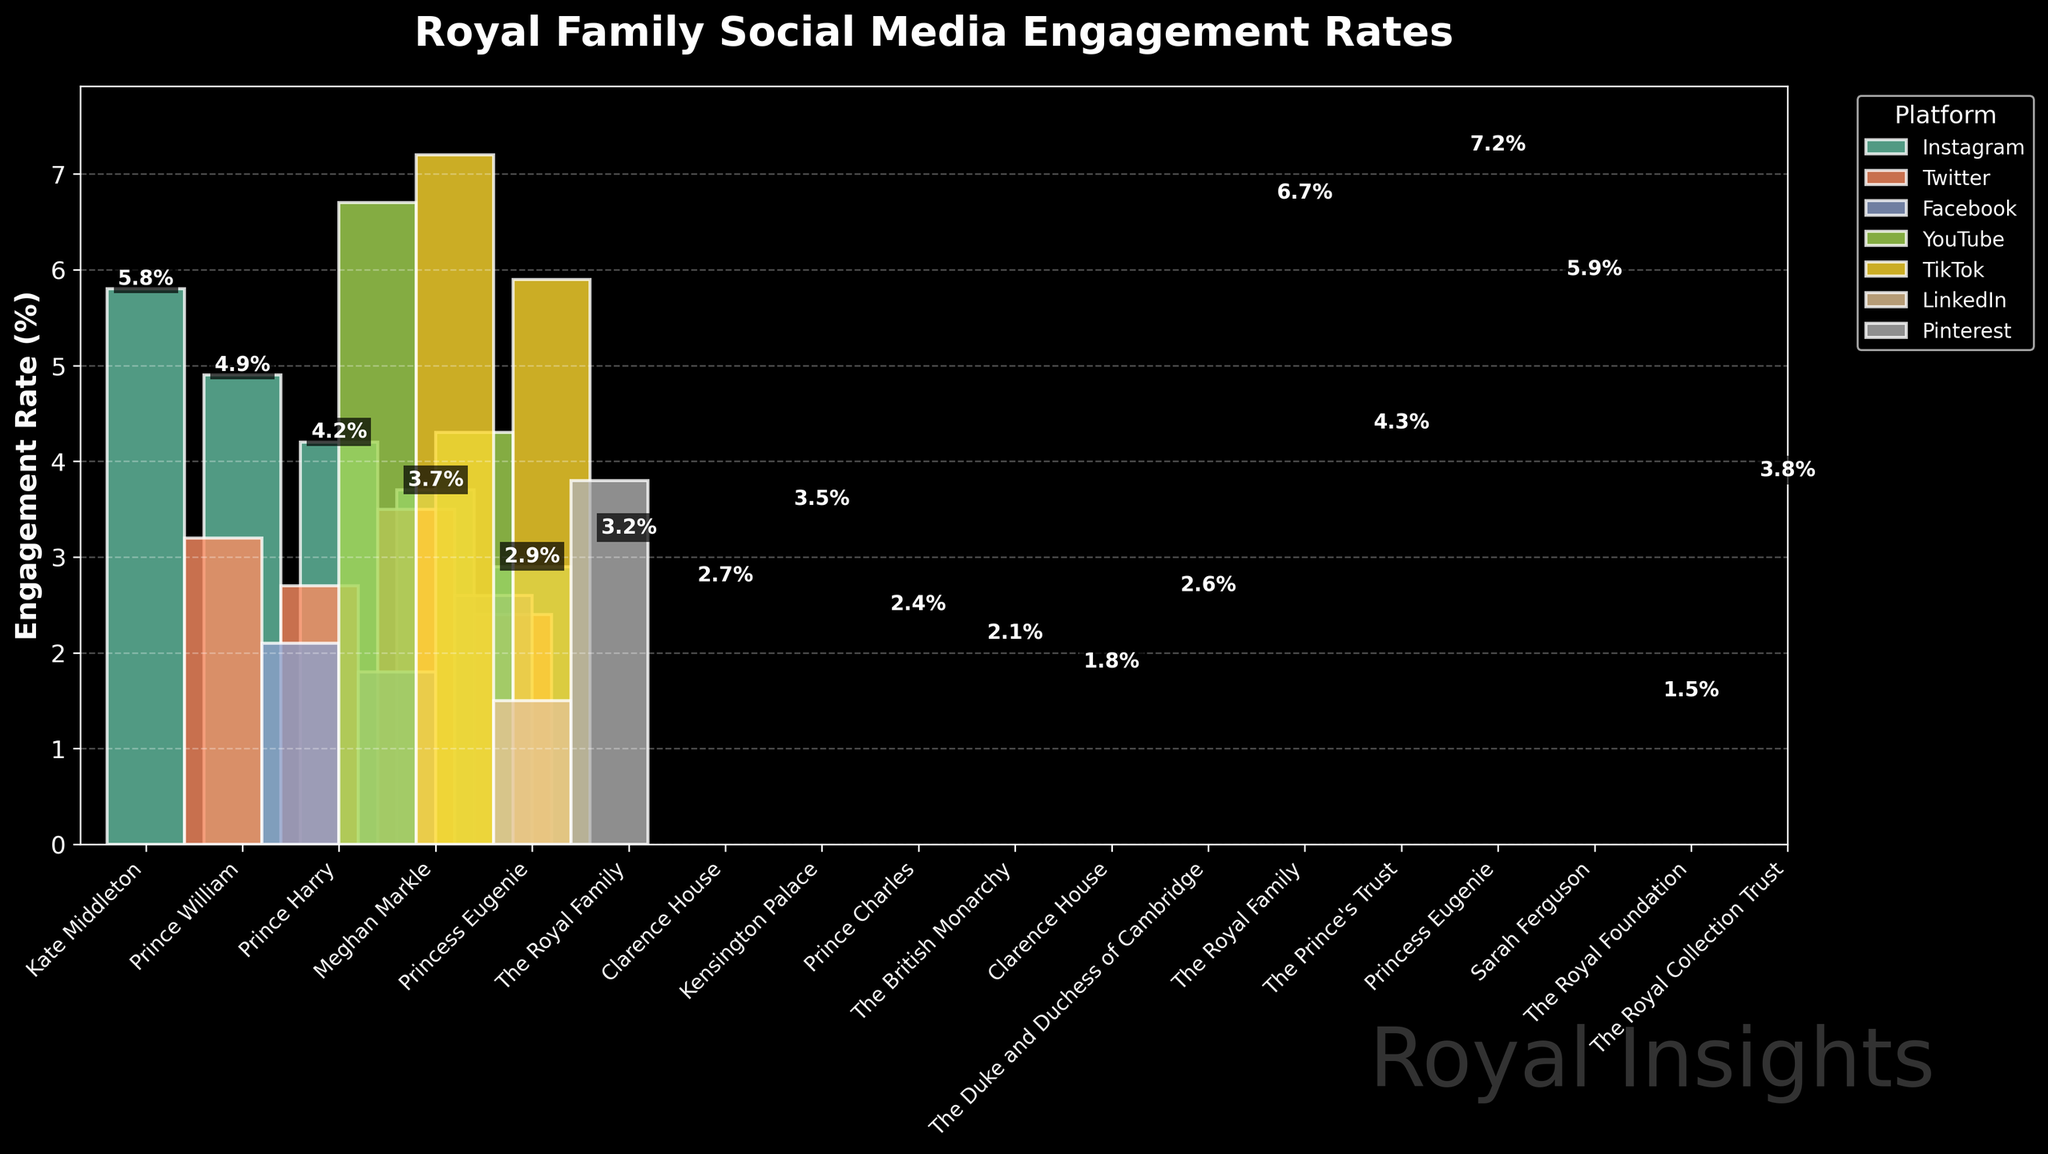What is the engagement rate of Kate Middleton on Instagram? Look for Kate Middleton under the Instagram platform and check the corresponding bar. The label shows an engagement rate of 5.8%.
Answer: 5.8% Who has a higher engagement rate on TikTok, Princess Eugenie or Sarah Ferguson? Compare the heights of the bars for Princess Eugenie and Sarah Ferguson under the TikTok platform. Princess Eugenie has a higher bar with an engagement rate of 7.2%, compared to Sarah Ferguson's 5.9%.
Answer: Princess Eugenie On which platform does the Royal Family have the highest engagement rate and what is the value? Look for the Royal Family across all platforms. On YouTube, the bar labeled The Royal Family shows the highest engagement rate with a value of 6.7%.
Answer: YouTube with 6.7% What is the difference in engagement rates between The Royal Family on YouTube and The Royal Family on Twitter? Check the bars for The Royal Family on YouTube and Twitter. The YouTube engagement rate is 6.7%, and the Twitter engagement rate is 3.2%. The difference is 6.7% - 3.2% = 3.5%.
Answer: 3.5% Which platform has the lowest engagement rate, and which Royal Family member is it associated with? Look for the shortest bar on the chart. The bar for The Royal Foundation on LinkedIn shows the lowest engagement rate of 1.5%.
Answer: LinkedIn, The Royal Foundation Which Royal Family member on Instagram has the lowest engagement rate? Compare the bars under the Instagram platform. Meghan Markle has the lowest engagement rate with a value of 3.7%.
Answer: Meghan Markle What is the average engagement rate on Facebook for all Royal accounts? Identify all the bars under Facebook: The British Monarchy (2.1%), Clarence House (1.8%), The Duke and Duchess of Cambridge (2.6%). Sum these rates: 2.1% + 1.8% + 2.6% = 6.5%. Then divide by the number of accounts: 6.5% / 3 ≈ 2.17%.
Answer: 2.17% How does Princess Eugenie's engagement rate on TikTok compare to her engagement rate on Instagram? Look at the bars for Princess Eugenie on both TikTok and Instagram. On TikTok, Princess Eugenie's engagement rate is 7.2%, and on Instagram, it is 2.9%. 7.2% - 2.9% = 4.3%.
Answer: 4.3% higher on TikTok Across all platforms, which individual or organization has the highest engagement rate, and what is it? Identify the highest bar across the entire chart. Princess Eugenie on TikTok has the highest engagement rate of 7.2%.
Answer: Princess Eugenie on TikTok with 7.2% 